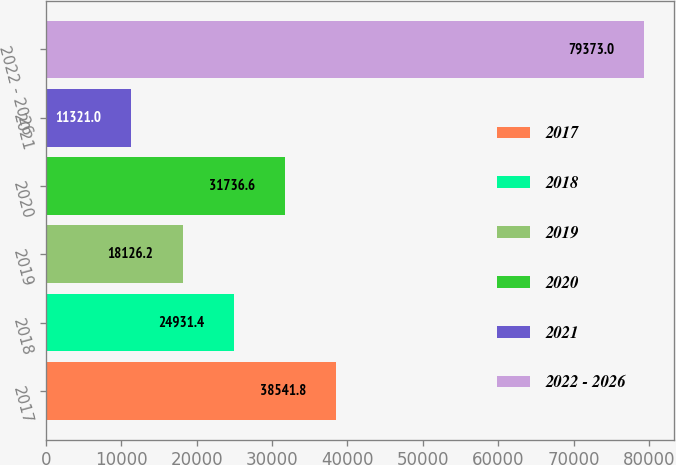<chart> <loc_0><loc_0><loc_500><loc_500><bar_chart><fcel>2017<fcel>2018<fcel>2019<fcel>2020<fcel>2021<fcel>2022 - 2026<nl><fcel>38541.8<fcel>24931.4<fcel>18126.2<fcel>31736.6<fcel>11321<fcel>79373<nl></chart> 